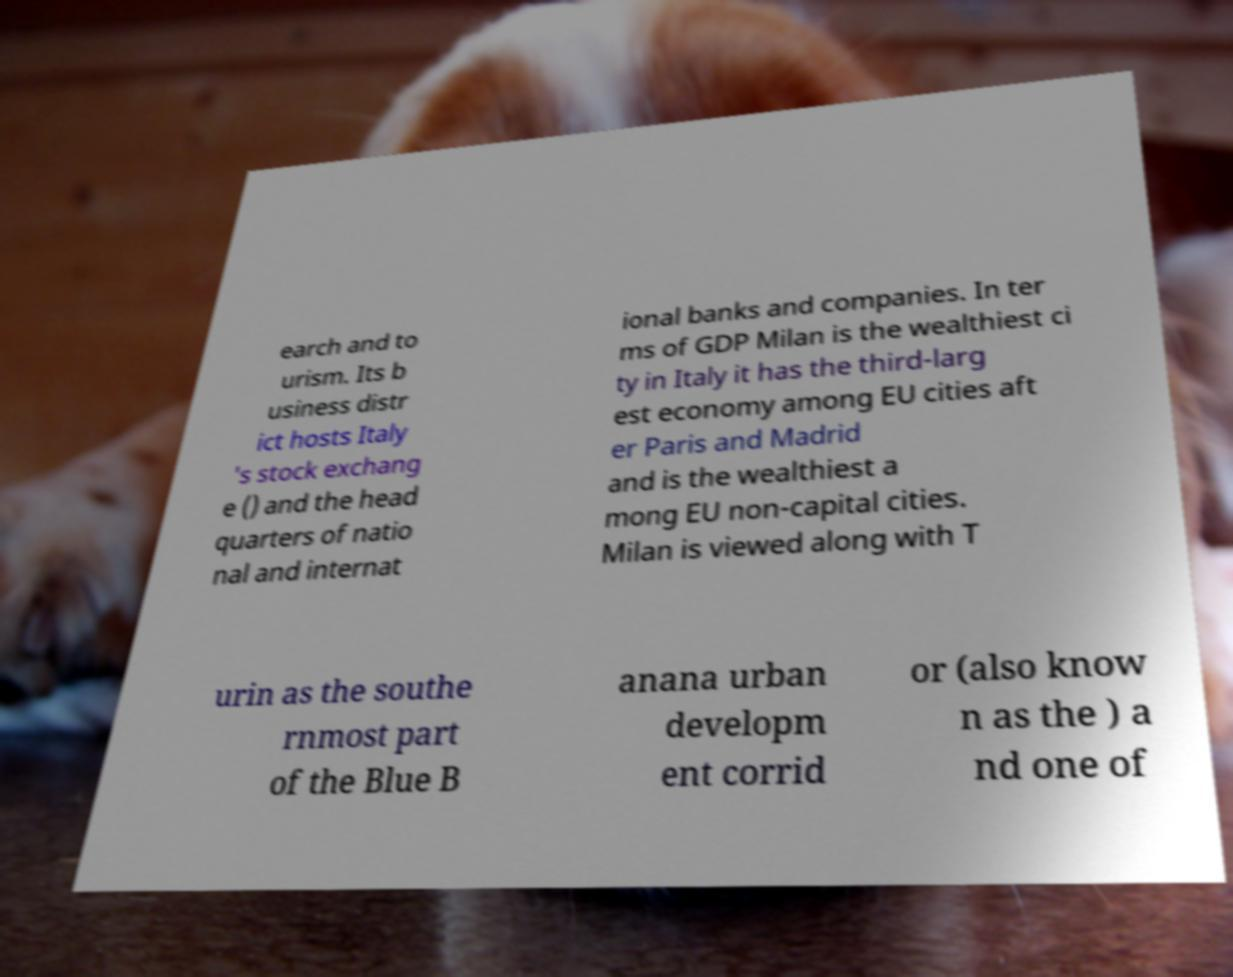Could you extract and type out the text from this image? earch and to urism. Its b usiness distr ict hosts Italy 's stock exchang e () and the head quarters of natio nal and internat ional banks and companies. In ter ms of GDP Milan is the wealthiest ci ty in Italy it has the third-larg est economy among EU cities aft er Paris and Madrid and is the wealthiest a mong EU non-capital cities. Milan is viewed along with T urin as the southe rnmost part of the Blue B anana urban developm ent corrid or (also know n as the ) a nd one of 